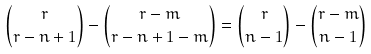<formula> <loc_0><loc_0><loc_500><loc_500>\binom { r } { r - n + 1 } - \binom { r - m } { r - n + 1 - m } = \binom { r } { n - 1 } - \binom { r - m } { n - 1 }</formula> 